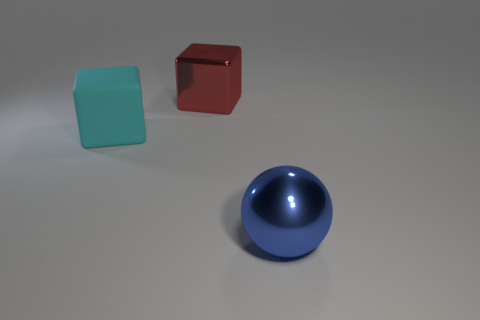Add 1 cyan matte cubes. How many objects exist? 4 Subtract all cyan blocks. How many blocks are left? 1 Add 2 tiny things. How many tiny things exist? 2 Subtract 0 gray cylinders. How many objects are left? 3 Subtract all spheres. How many objects are left? 2 Subtract 1 balls. How many balls are left? 0 Subtract all red spheres. Subtract all gray cubes. How many spheres are left? 1 Subtract all brown cylinders. How many cyan cubes are left? 1 Subtract all red metallic things. Subtract all blue shiny objects. How many objects are left? 1 Add 3 blue objects. How many blue objects are left? 4 